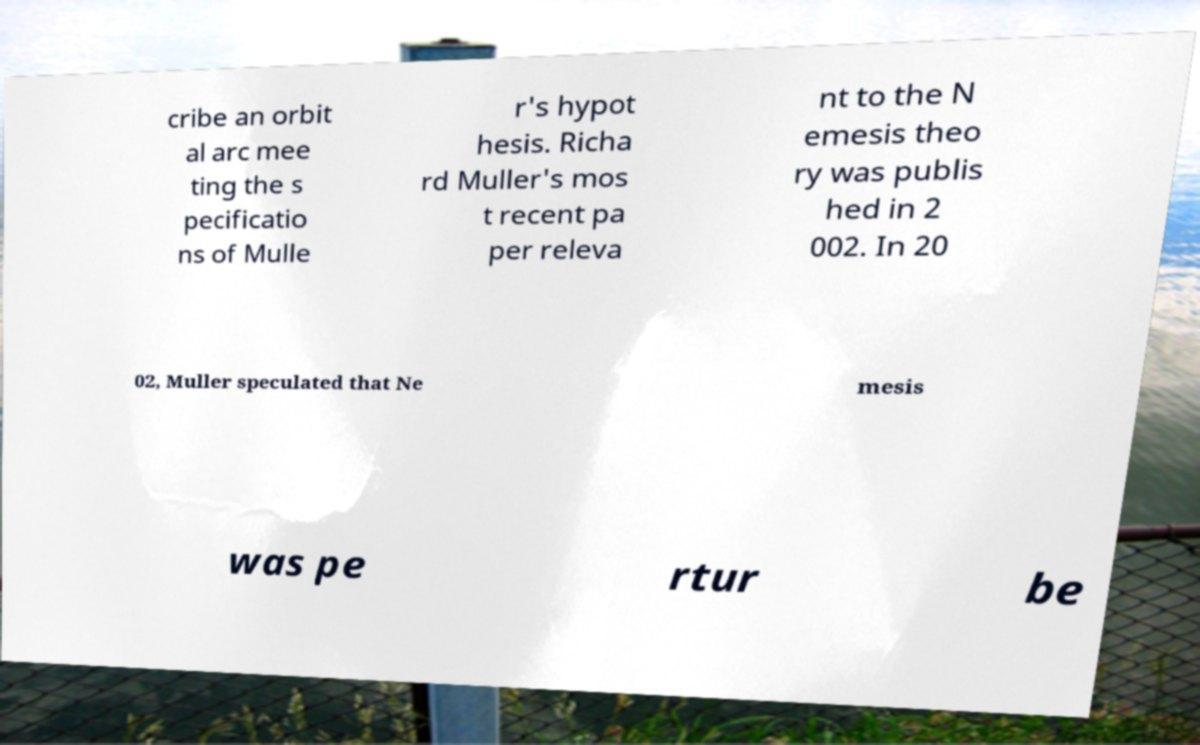What messages or text are displayed in this image? I need them in a readable, typed format. cribe an orbit al arc mee ting the s pecificatio ns of Mulle r's hypot hesis. Richa rd Muller's mos t recent pa per releva nt to the N emesis theo ry was publis hed in 2 002. In 20 02, Muller speculated that Ne mesis was pe rtur be 